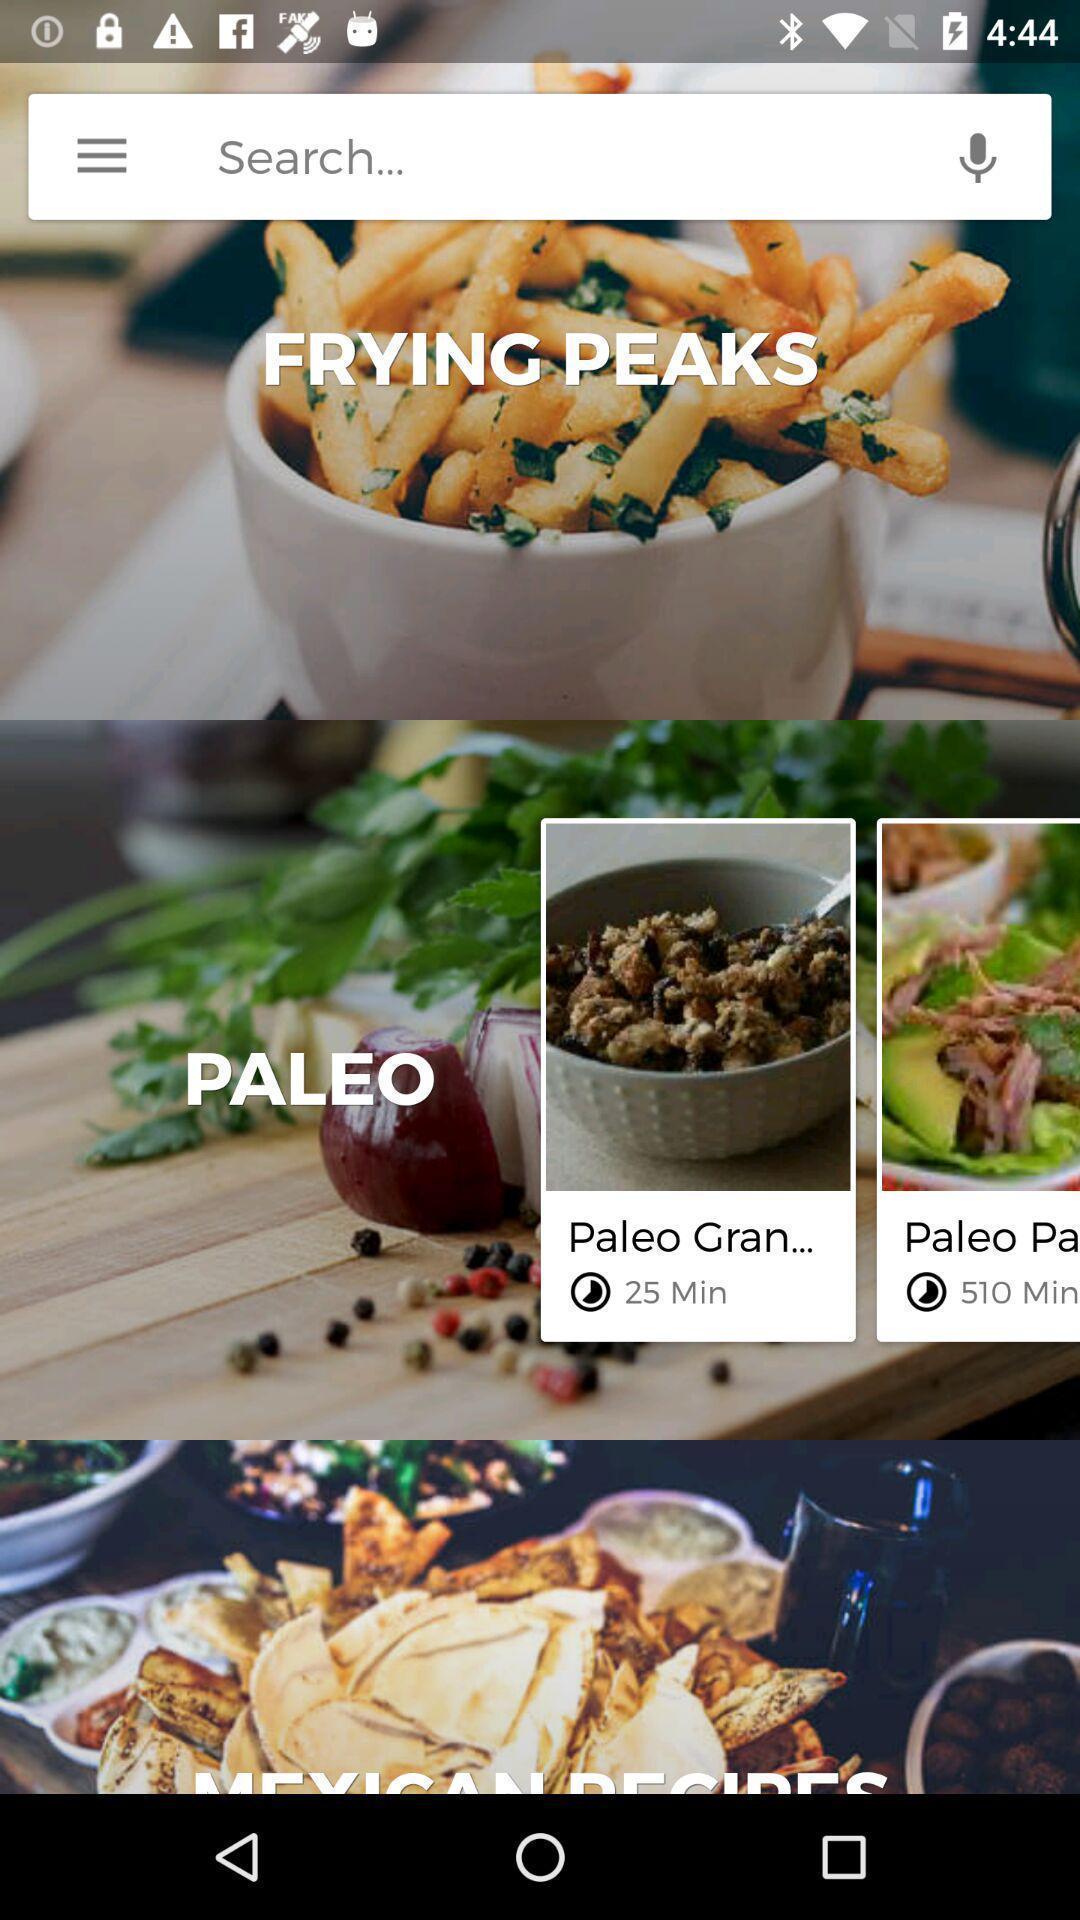Provide a description of this screenshot. Search bar in the application to find various food items. 